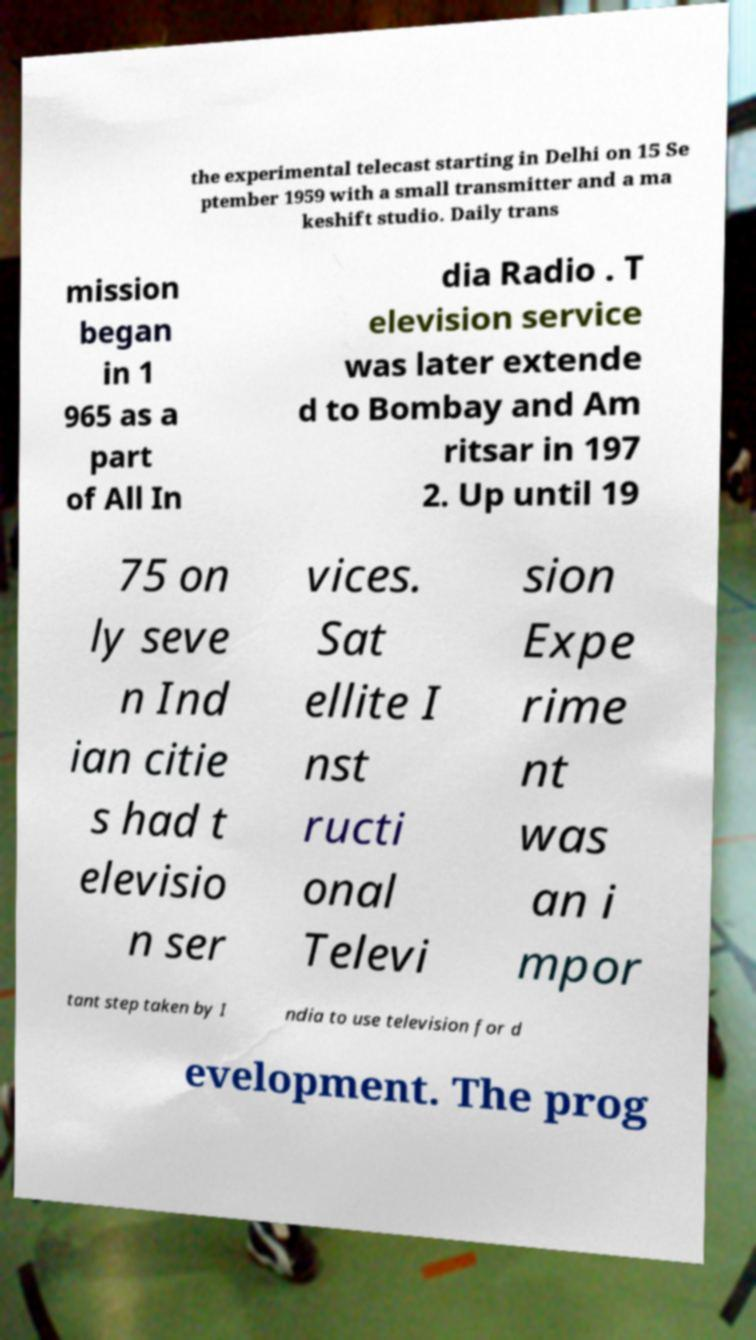Please identify and transcribe the text found in this image. the experimental telecast starting in Delhi on 15 Se ptember 1959 with a small transmitter and a ma keshift studio. Daily trans mission began in 1 965 as a part of All In dia Radio . T elevision service was later extende d to Bombay and Am ritsar in 197 2. Up until 19 75 on ly seve n Ind ian citie s had t elevisio n ser vices. Sat ellite I nst ructi onal Televi sion Expe rime nt was an i mpor tant step taken by I ndia to use television for d evelopment. The prog 